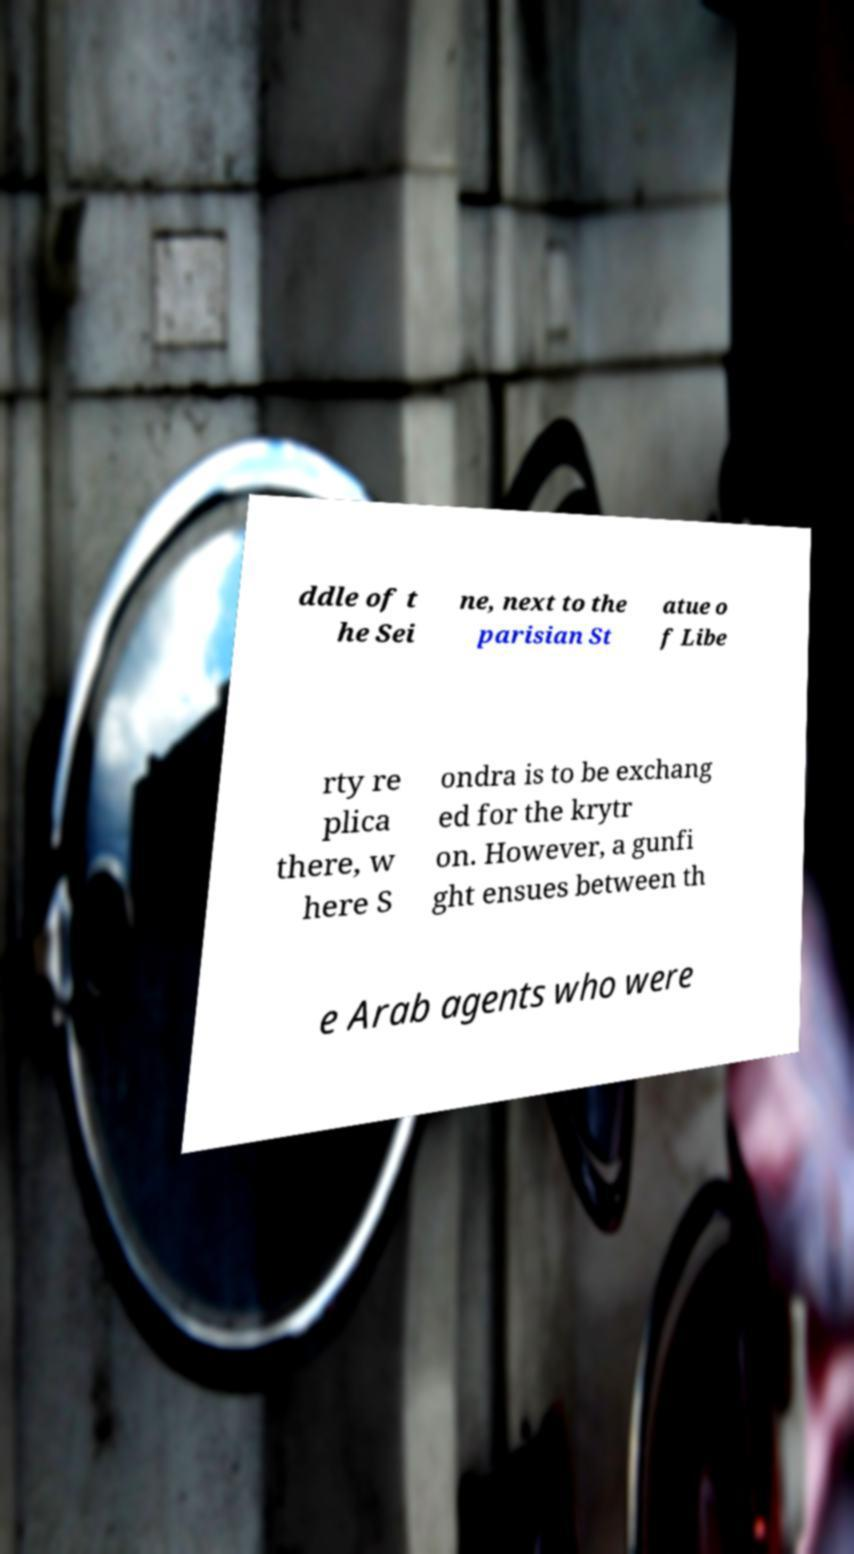Please read and relay the text visible in this image. What does it say? ddle of t he Sei ne, next to the parisian St atue o f Libe rty re plica there, w here S ondra is to be exchang ed for the krytr on. However, a gunfi ght ensues between th e Arab agents who were 